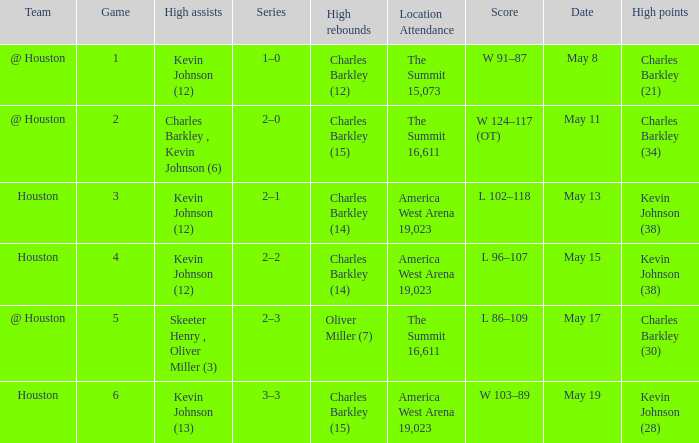In how many different games did Oliver Miller (7) did the high rebounds? 1.0. 